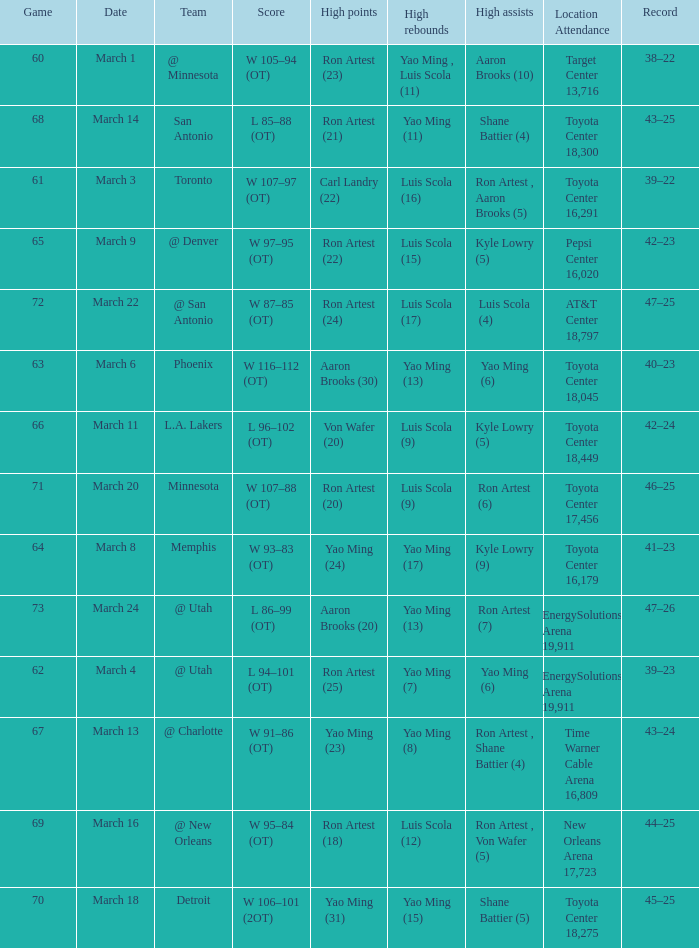Who had the most poinst in game 72? Ron Artest (24). 